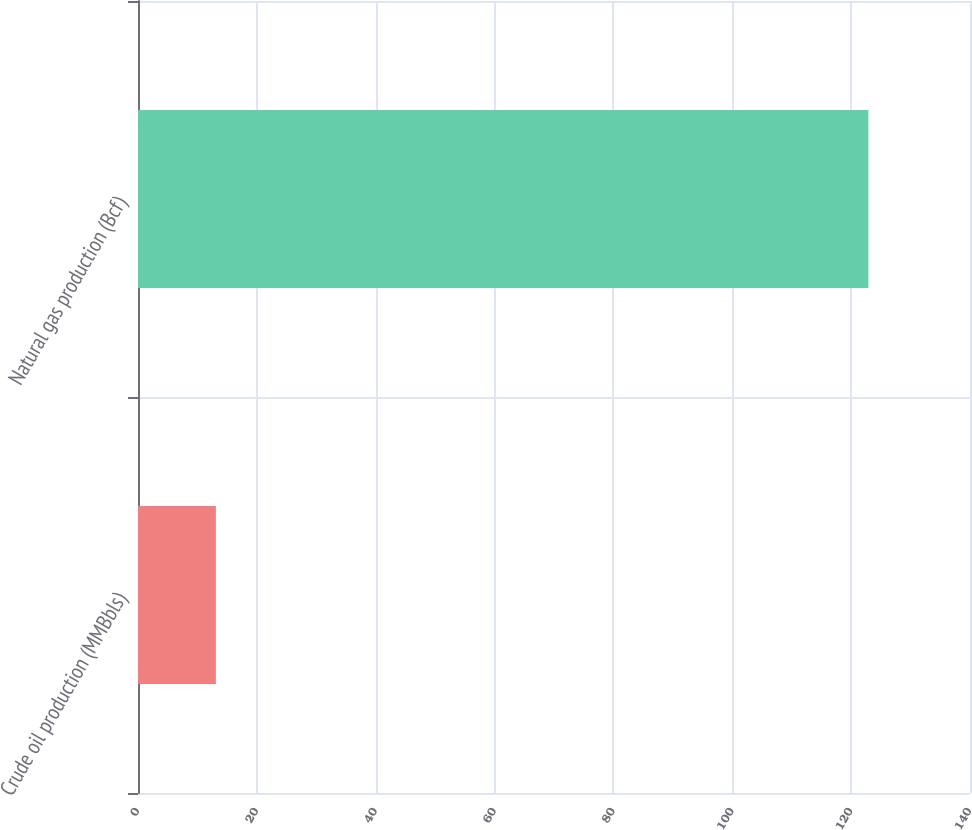Convert chart. <chart><loc_0><loc_0><loc_500><loc_500><bar_chart><fcel>Crude oil production (MMBbls)<fcel>Natural gas production (Bcf)<nl><fcel>13.1<fcel>122.9<nl></chart> 